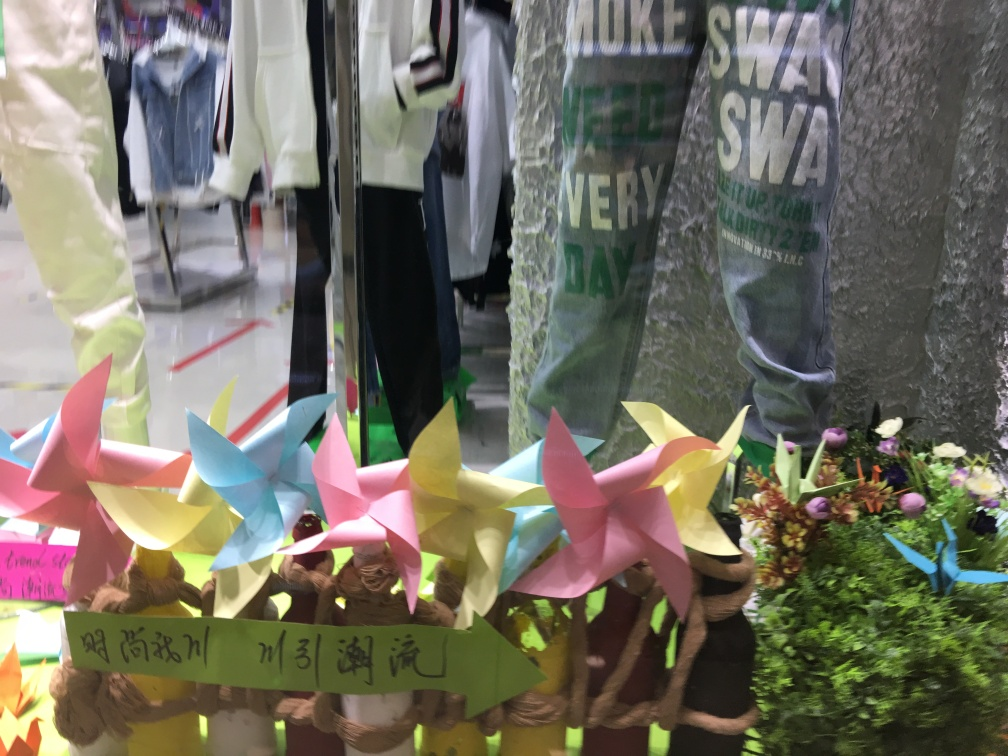What is the quality of this image?
A. Superb
B. Okay
C. Satisfactory While the image is somewhat clear, there are reflections and a lack of focus on the primary subjects that affect its overall quality. It captures an interesting array of colors and objects, like the pinwheels and flowers, but the reflections on the glass make it challenging to discern details. Therefore, it's rated as 'okay' since, despite its artistic and vibrant content, the technical quality could be improved for better clarity. 